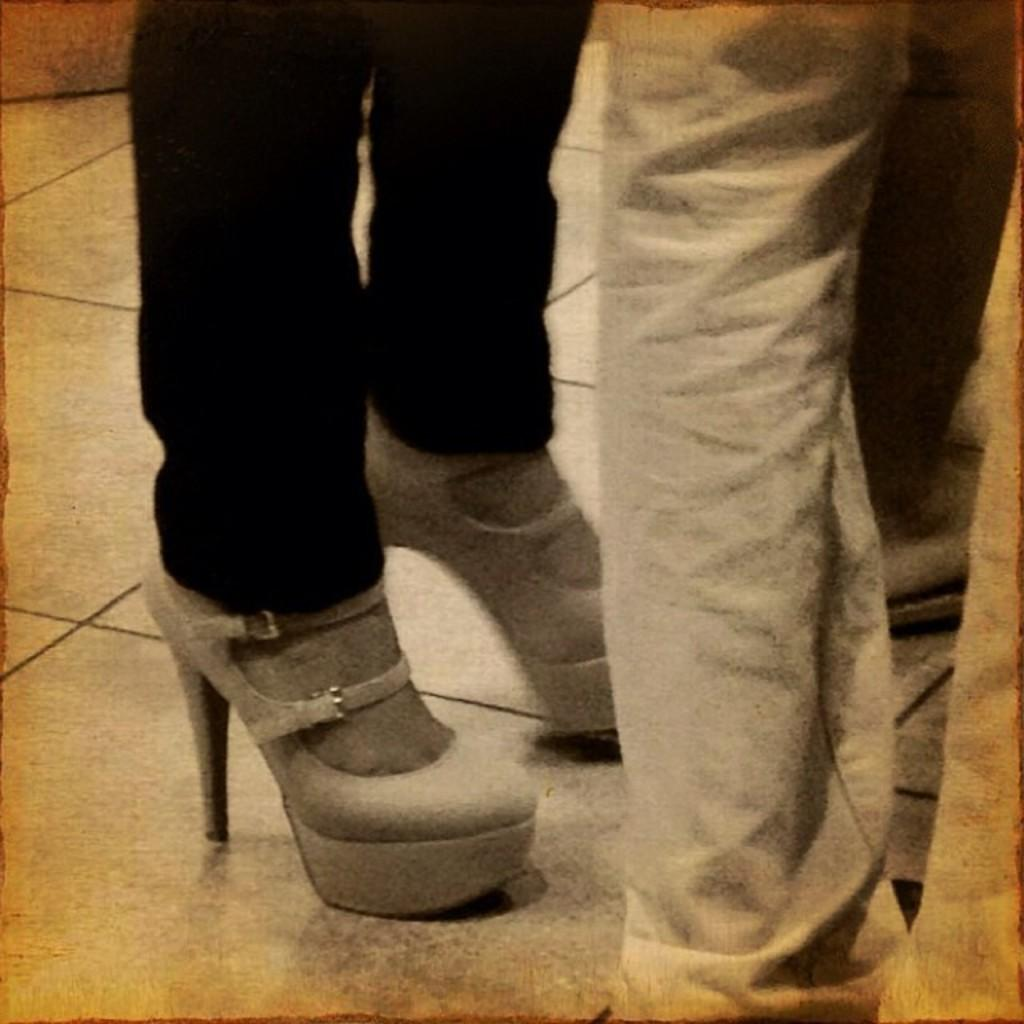What can be seen at the bottom of the image? There are legs of people visible in the image. What type of clothing is present on the feet of a person in the image? The footwear of a person is present in the image. What type of suit can be seen in the image? There is no suit present in the image. 